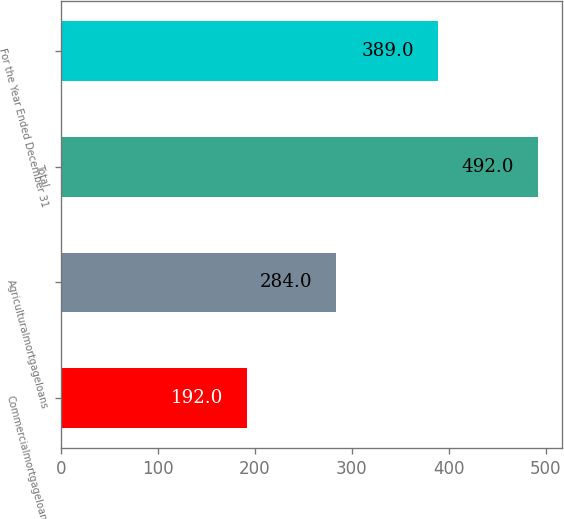Convert chart to OTSL. <chart><loc_0><loc_0><loc_500><loc_500><bar_chart><fcel>Commercialmortgageloans<fcel>Agriculturalmortgageloans<fcel>Total<fcel>For the Year Ended December 31<nl><fcel>192<fcel>284<fcel>492<fcel>389<nl></chart> 